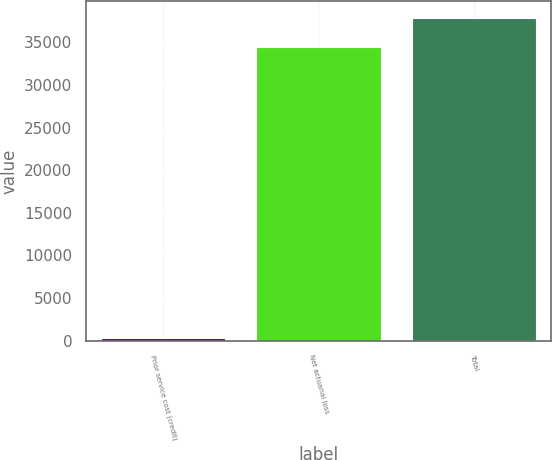Convert chart. <chart><loc_0><loc_0><loc_500><loc_500><bar_chart><fcel>Prior service cost (credit)<fcel>Net actuarial loss<fcel>Total<nl><fcel>274<fcel>34445<fcel>37889.5<nl></chart> 